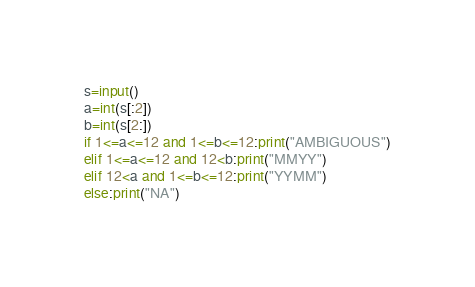<code> <loc_0><loc_0><loc_500><loc_500><_Python_>s=input()
a=int(s[:2])
b=int(s[2:])
if 1<=a<=12 and 1<=b<=12:print("AMBIGUOUS")
elif 1<=a<=12 and 12<b:print("MMYY")
elif 12<a and 1<=b<=12:print("YYMM")
else:print("NA")</code> 